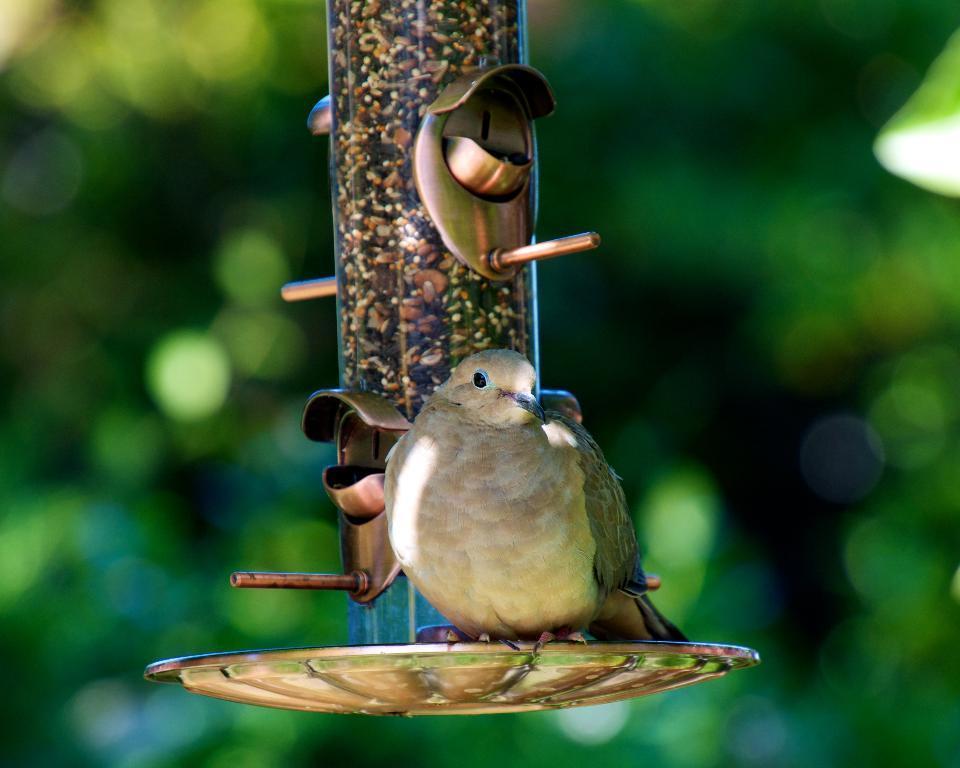Could you give a brief overview of what you see in this image? In this picture I can observe a bird. The bird is in cream color. I can observe a pole in the middle of the picture. The background is completely blurred which is in cream color. 